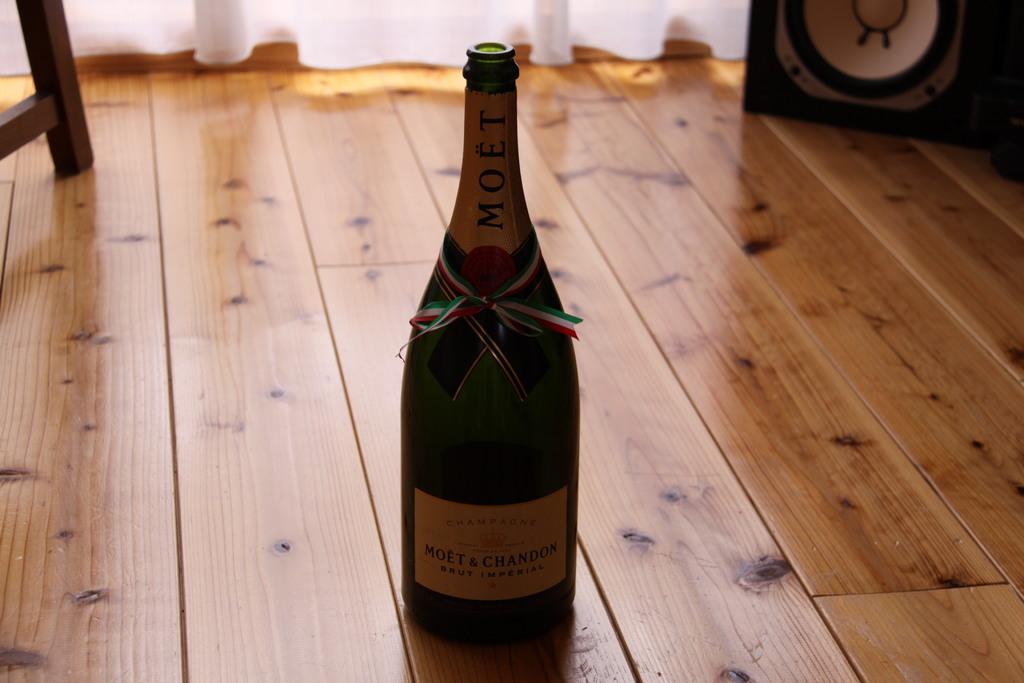What brand is this champagne?
Keep it short and to the point. Moet. 